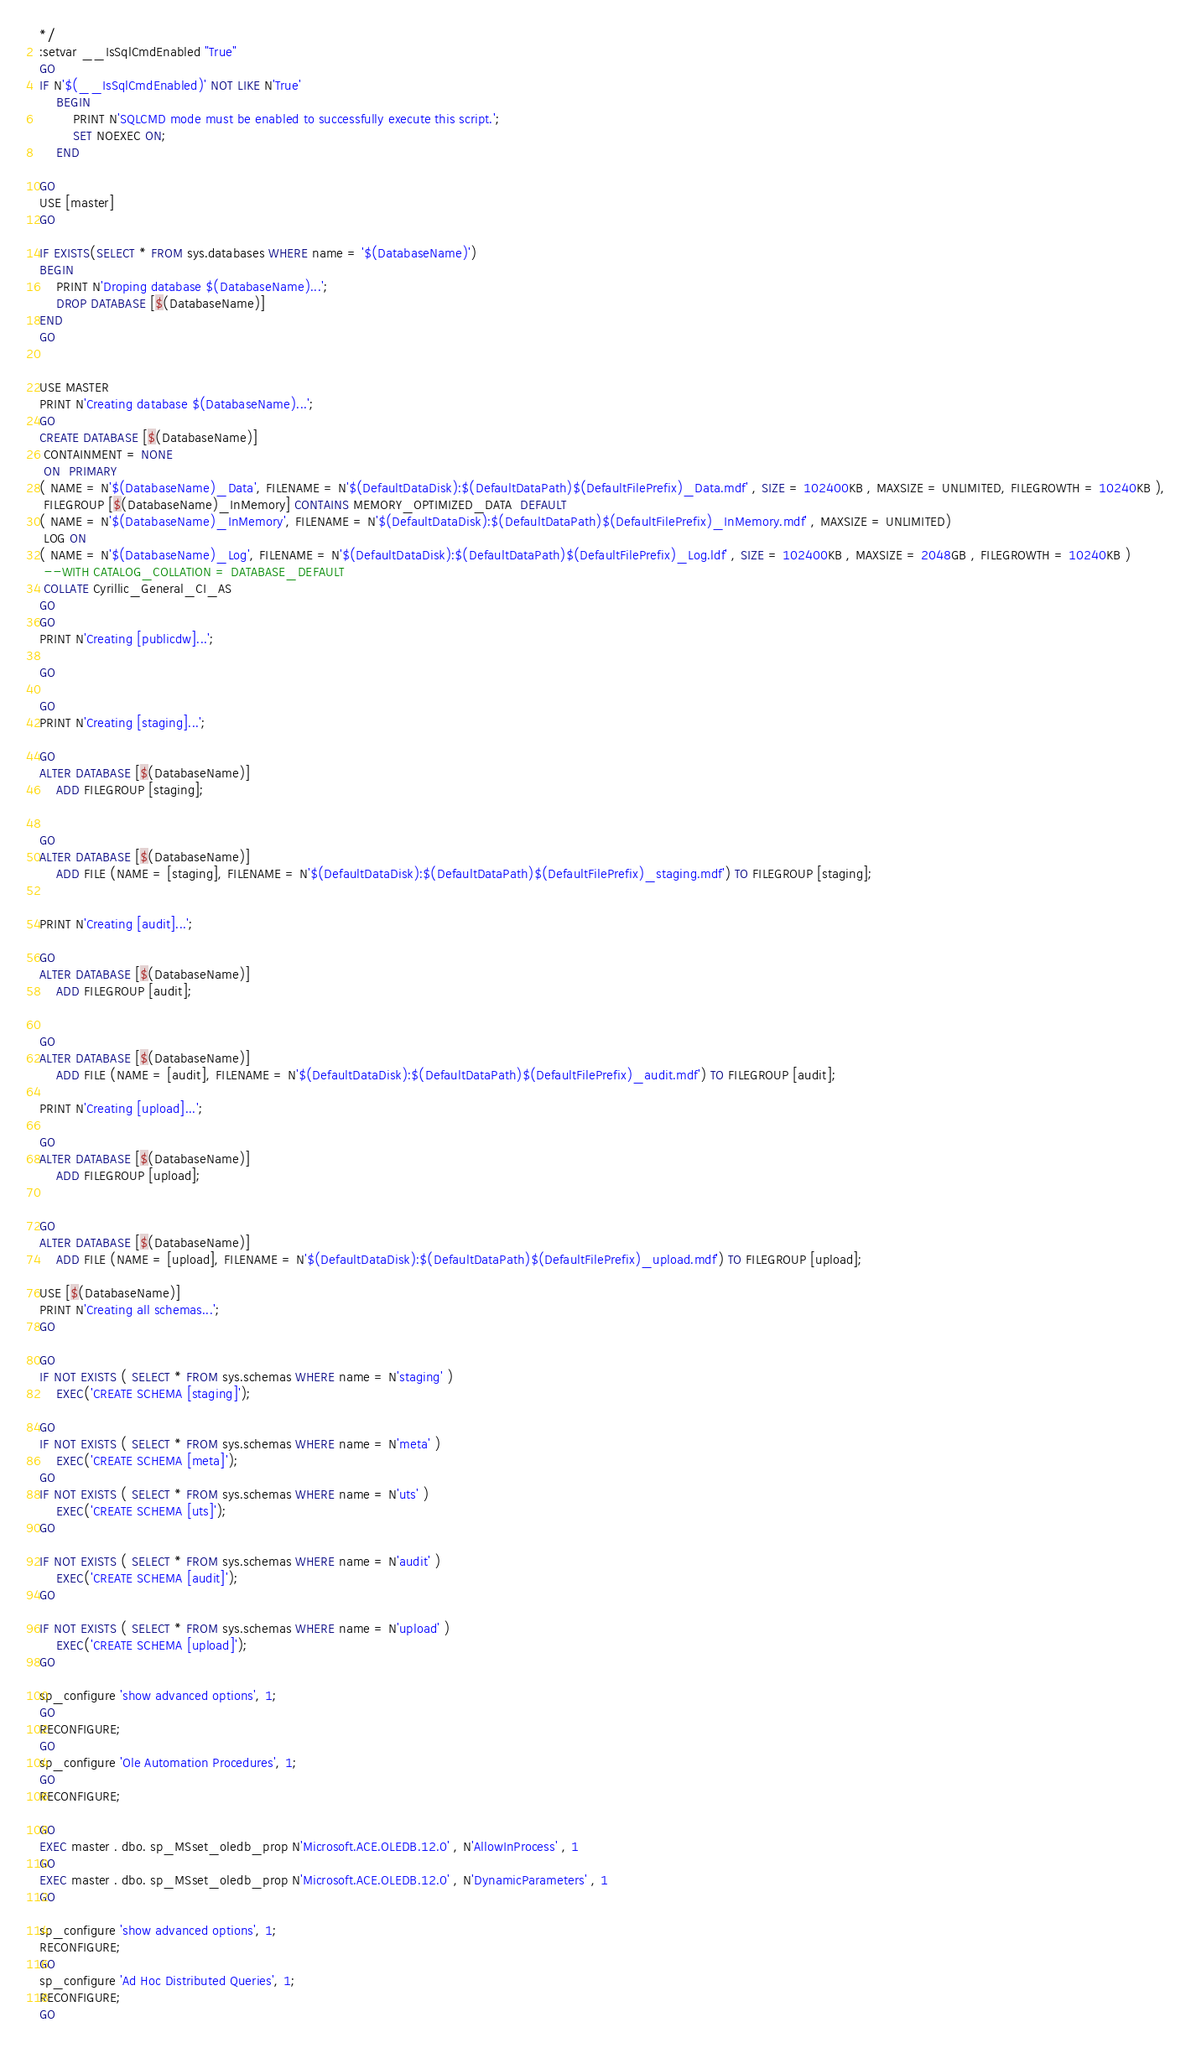Convert code to text. <code><loc_0><loc_0><loc_500><loc_500><_SQL_>*/
:setvar __IsSqlCmdEnabled "True"
GO
IF N'$(__IsSqlCmdEnabled)' NOT LIKE N'True'
    BEGIN
        PRINT N'SQLCMD mode must be enabled to successfully execute this script.';
        SET NOEXEC ON;
    END

GO
USE [master]
GO

IF EXISTS(SELECT * FROM sys.databases WHERE name = '$(DatabaseName)')
BEGIN
    PRINT N'Droping database $(DatabaseName)...';
	DROP DATABASE [$(DatabaseName)]
END
GO


USE MASTER
PRINT N'Creating database $(DatabaseName)...';
GO
CREATE DATABASE [$(DatabaseName)] 
 CONTAINMENT = NONE 
 ON  PRIMARY 
( NAME = N'$(DatabaseName)_Data', FILENAME = N'$(DefaultDataDisk):$(DefaultDataPath)$(DefaultFilePrefix)_Data.mdf' , SIZE = 102400KB , MAXSIZE = UNLIMITED, FILEGROWTH = 10240KB ), 
 FILEGROUP [$(DatabaseName)_InMemory] CONTAINS MEMORY_OPTIMIZED_DATA  DEFAULT
( NAME = N'$(DatabaseName)_InMemory', FILENAME = N'$(DefaultDataDisk):$(DefaultDataPath)$(DefaultFilePrefix)_InMemory.mdf' , MAXSIZE = UNLIMITED)
 LOG ON 
( NAME = N'$(DatabaseName)_Log', FILENAME = N'$(DefaultDataDisk):$(DefaultDataPath)$(DefaultFilePrefix)_Log.ldf' , SIZE = 102400KB , MAXSIZE = 2048GB , FILEGROWTH = 10240KB )
 --WITH CATALOG_COLLATION = DATABASE_DEFAULT
 COLLATE Cyrillic_General_CI_AS
GO
GO
PRINT N'Creating [publicdw]...';

GO

GO
PRINT N'Creating [staging]...';

GO
ALTER DATABASE [$(DatabaseName)]
    ADD FILEGROUP [staging];


GO
ALTER DATABASE [$(DatabaseName)]
    ADD FILE (NAME = [staging], FILENAME = N'$(DefaultDataDisk):$(DefaultDataPath)$(DefaultFilePrefix)_staging.mdf') TO FILEGROUP [staging];


PRINT N'Creating [audit]...';

GO
ALTER DATABASE [$(DatabaseName)]
    ADD FILEGROUP [audit];


GO
ALTER DATABASE [$(DatabaseName)]
    ADD FILE (NAME = [audit], FILENAME = N'$(DefaultDataDisk):$(DefaultDataPath)$(DefaultFilePrefix)_audit.mdf') TO FILEGROUP [audit];

PRINT N'Creating [upload]...';

GO
ALTER DATABASE [$(DatabaseName)]
    ADD FILEGROUP [upload];


GO
ALTER DATABASE [$(DatabaseName)]
    ADD FILE (NAME = [upload], FILENAME = N'$(DefaultDataDisk):$(DefaultDataPath)$(DefaultFilePrefix)_upload.mdf') TO FILEGROUP [upload];

USE [$(DatabaseName)] 
PRINT N'Creating all schemas...';
GO

GO
IF NOT EXISTS ( SELECT * FROM sys.schemas WHERE name = N'staging' )
    EXEC('CREATE SCHEMA [staging]');

GO
IF NOT EXISTS ( SELECT * FROM sys.schemas WHERE name = N'meta' )
    EXEC('CREATE SCHEMA [meta]');
GO
IF NOT EXISTS ( SELECT * FROM sys.schemas WHERE name = N'uts' )
    EXEC('CREATE SCHEMA [uts]');
GO

IF NOT EXISTS ( SELECT * FROM sys.schemas WHERE name = N'audit' )
    EXEC('CREATE SCHEMA [audit]');
GO

IF NOT EXISTS ( SELECT * FROM sys.schemas WHERE name = N'upload' )
    EXEC('CREATE SCHEMA [upload]');
GO

sp_configure 'show advanced options', 1;
GO
RECONFIGURE;
GO
sp_configure 'Ole Automation Procedures', 1;
GO
RECONFIGURE;

GO
EXEC master . dbo. sp_MSset_oledb_prop N'Microsoft.ACE.OLEDB.12.0' , N'AllowInProcess' , 1
GO
EXEC master . dbo. sp_MSset_oledb_prop N'Microsoft.ACE.OLEDB.12.0' , N'DynamicParameters' , 1
GO

sp_configure 'show advanced options', 1;
RECONFIGURE;
GO        
sp_configure 'Ad Hoc Distributed Queries', 1;
RECONFIGURE;
GO</code> 